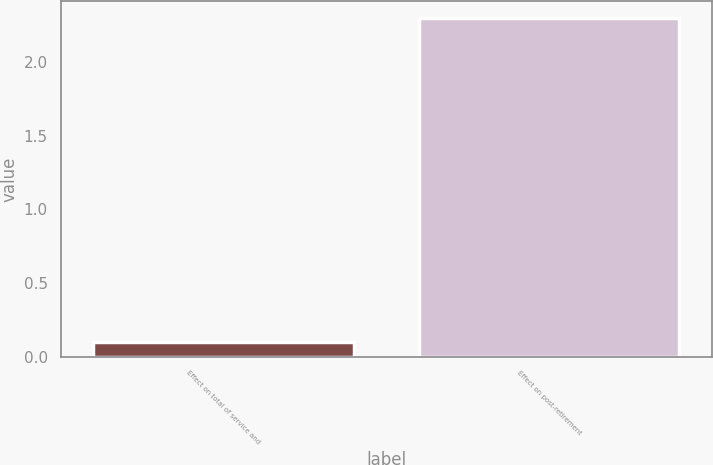Convert chart to OTSL. <chart><loc_0><loc_0><loc_500><loc_500><bar_chart><fcel>Effect on total of service and<fcel>Effect on post-retirement<nl><fcel>0.1<fcel>2.3<nl></chart> 